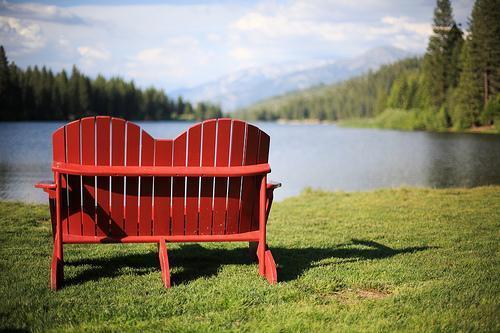How many people could sit in the chair shown?
Give a very brief answer. 2. 